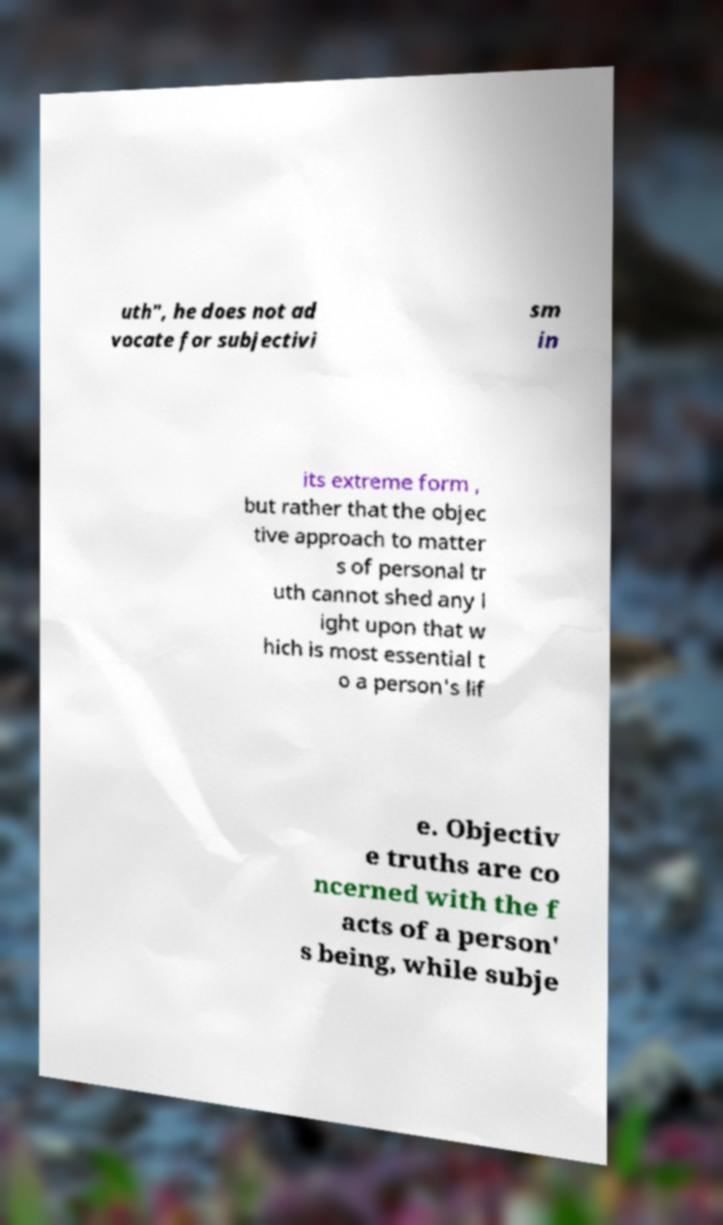I need the written content from this picture converted into text. Can you do that? uth", he does not ad vocate for subjectivi sm in its extreme form , but rather that the objec tive approach to matter s of personal tr uth cannot shed any l ight upon that w hich is most essential t o a person's lif e. Objectiv e truths are co ncerned with the f acts of a person' s being, while subje 